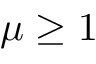Convert formula to latex. <formula><loc_0><loc_0><loc_500><loc_500>\mu \geq 1</formula> 